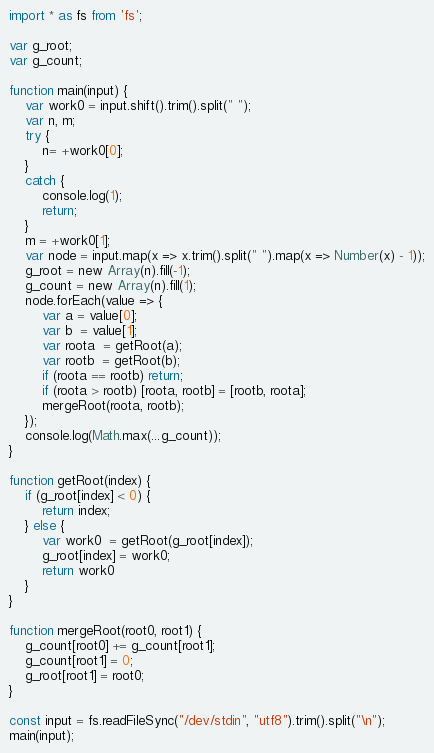<code> <loc_0><loc_0><loc_500><loc_500><_TypeScript_>import * as fs from 'fs';

var g_root;
var g_count;

function main(input) {
	var work0 = input.shift().trim().split(" ");
	var n, m;
	try {
		n= +work0[0];
	}
	catch {
		console.log(1);
		return;
	}
	m = +work0[1];
	var node = input.map(x => x.trim().split(" ").map(x => Number(x) - 1));
	g_root = new Array(n).fill(-1);
	g_count = new Array(n).fill(1);
	node.forEach(value => {
		var a = value[0];
		var b  = value[1];
		var roota  = getRoot(a);
		var rootb  = getRoot(b);
		if (roota == rootb) return;
		if (roota > rootb) [roota, rootb] = [rootb, roota];
		mergeRoot(roota, rootb);
	});
	console.log(Math.max(...g_count));
}

function getRoot(index) {
	if (g_root[index] < 0) {
		return index;
	} else {
		var work0  = getRoot(g_root[index]);
		g_root[index] = work0;
		return work0
	}
}

function mergeRoot(root0, root1) {
	g_count[root0] += g_count[root1];
	g_count[root1] = 0;
	g_root[root1] = root0;
}

const input = fs.readFileSync("/dev/stdin", "utf8").trim().split("\n");
main(input);
</code> 